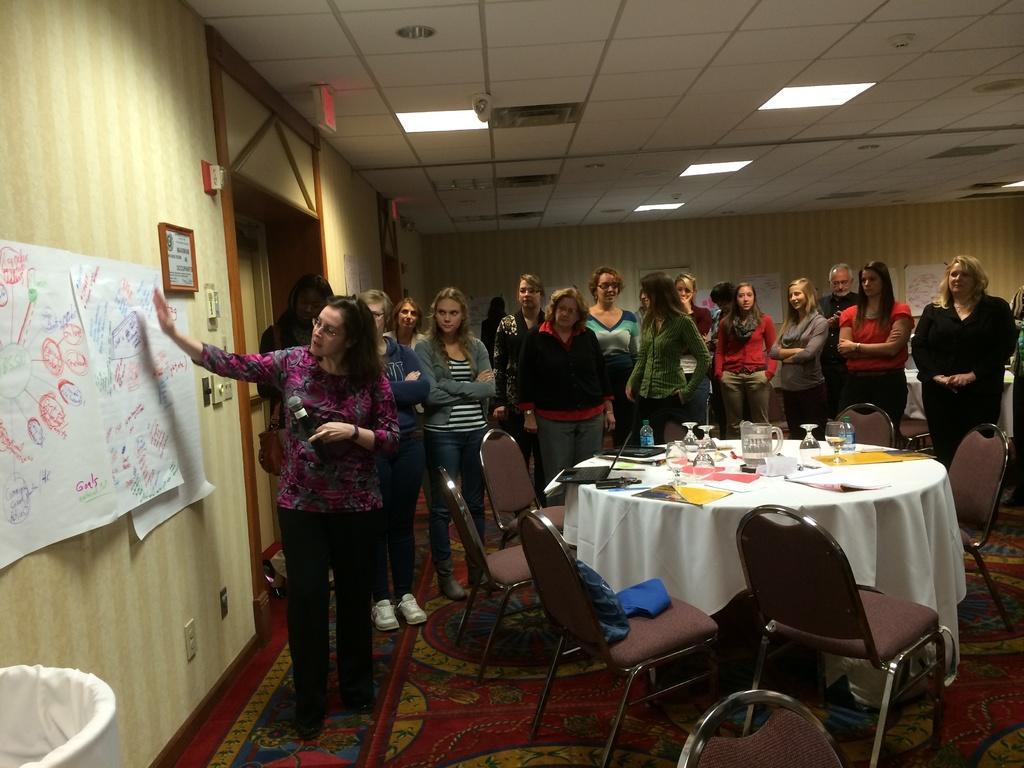Can you describe this image briefly? In this picture there is a woman who is standing near to the posters. In the background I can see many people were standing near to the table and chairs. On the table I can see the glasses, jars, papers, books and other objects. At the top I can see the lights. 